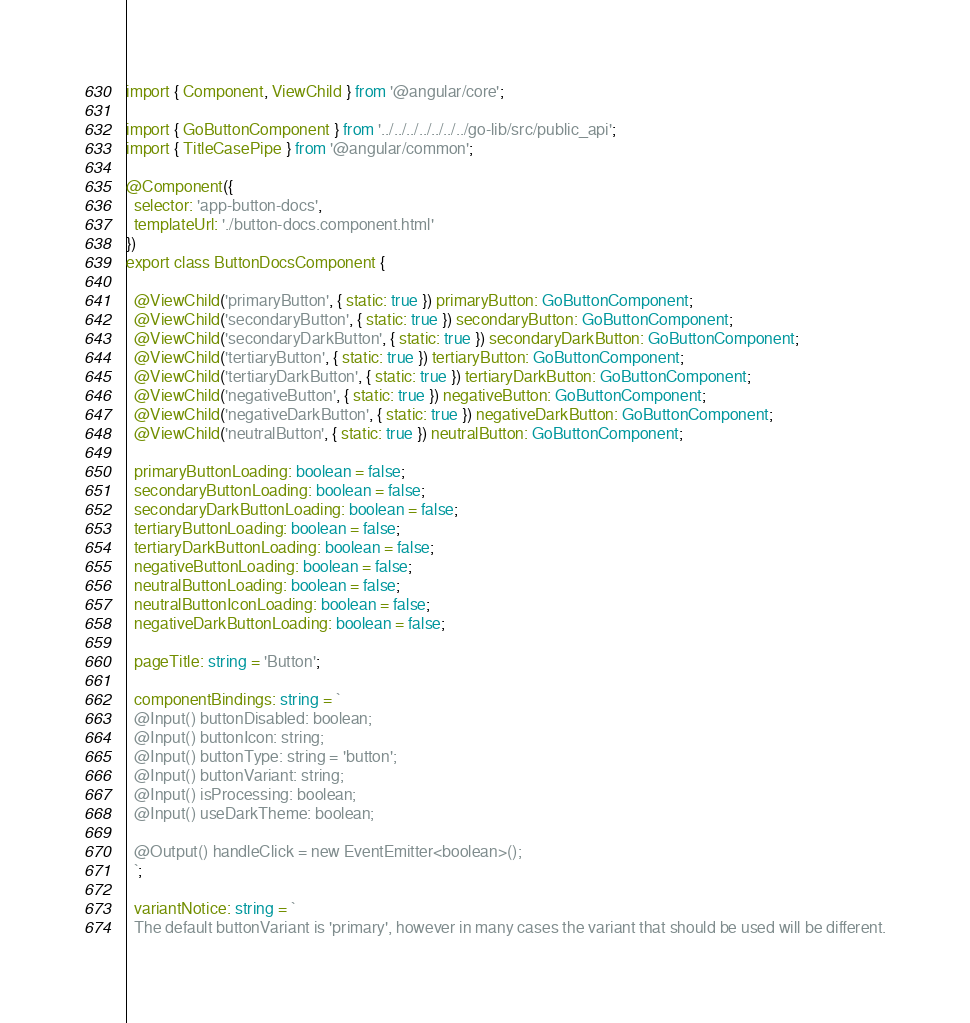Convert code to text. <code><loc_0><loc_0><loc_500><loc_500><_TypeScript_>import { Component, ViewChild } from '@angular/core';

import { GoButtonComponent } from '../../../../../../../go-lib/src/public_api';
import { TitleCasePipe } from '@angular/common';

@Component({
  selector: 'app-button-docs',
  templateUrl: './button-docs.component.html'
})
export class ButtonDocsComponent {

  @ViewChild('primaryButton', { static: true }) primaryButton: GoButtonComponent;
  @ViewChild('secondaryButton', { static: true }) secondaryButton: GoButtonComponent;
  @ViewChild('secondaryDarkButton', { static: true }) secondaryDarkButton: GoButtonComponent;
  @ViewChild('tertiaryButton', { static: true }) tertiaryButton: GoButtonComponent;
  @ViewChild('tertiaryDarkButton', { static: true }) tertiaryDarkButton: GoButtonComponent;
  @ViewChild('negativeButton', { static: true }) negativeButton: GoButtonComponent;
  @ViewChild('negativeDarkButton', { static: true }) negativeDarkButton: GoButtonComponent;
  @ViewChild('neutralButton', { static: true }) neutralButton: GoButtonComponent;

  primaryButtonLoading: boolean = false;
  secondaryButtonLoading: boolean = false;
  secondaryDarkButtonLoading: boolean = false;
  tertiaryButtonLoading: boolean = false;
  tertiaryDarkButtonLoading: boolean = false;
  negativeButtonLoading: boolean = false;
  neutralButtonLoading: boolean = false;
  neutralButtonIconLoading: boolean = false;
  negativeDarkButtonLoading: boolean = false;

  pageTitle: string = 'Button';

  componentBindings: string = `
  @Input() buttonDisabled: boolean;
  @Input() buttonIcon: string;
  @Input() buttonType: string = 'button';
  @Input() buttonVariant: string;
  @Input() isProcessing: boolean;
  @Input() useDarkTheme: boolean;

  @Output() handleClick = new EventEmitter<boolean>();
  `;

  variantNotice: string = `
  The default buttonVariant is 'primary', however in many cases the variant that should be used will be different.</code> 